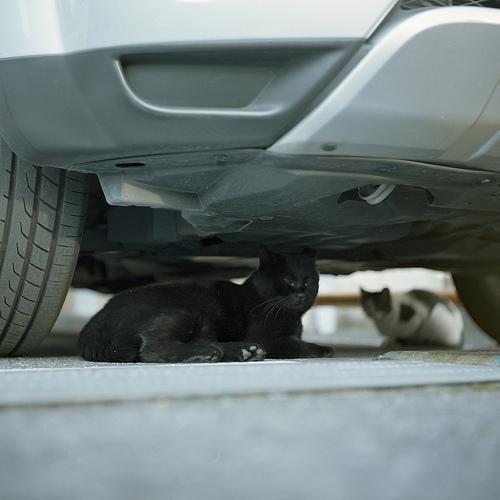How many cats under the car?
Give a very brief answer. 2. 